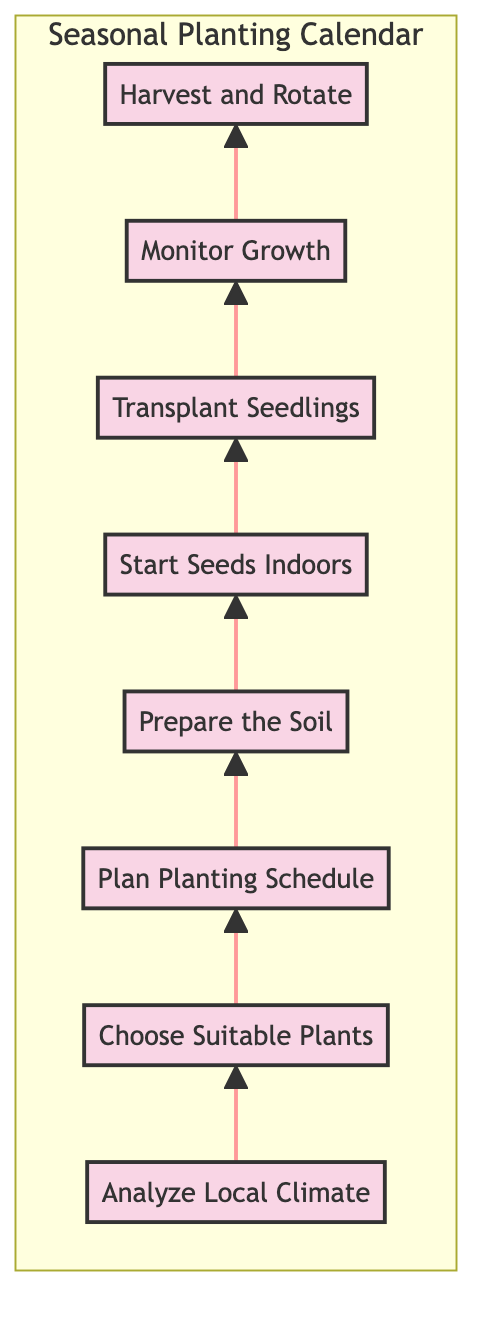What is the first step in the seasonal planting calendar? The first step is represented as the bottom node in the flowchart, which shows "Analyze Local Climate" as the initial action to take before any other steps.
Answer: Analyze Local Climate How many steps are there in total? Counting each step in the flowchart from the bottom to the top reveals there are eight distinct steps listed sequentially.
Answer: 8 What comes after "Prepare the Soil"? By following the arrows in the flowchart, we see that "Start Seeds Indoors" directly follows "Prepare the Soil" as the next step in the process.
Answer: Start Seeds Indoors Which step involves monitoring plants for issues? Referring to the flowchart, the step labeled "Monitor Growth" explicitly describes the actions of checking for pests, diseases, and nutrient deficiencies.
Answer: Monitor Growth What is the last step in the sequence? The last step in the flowchart is the topmost node, which indicates the final action to complete the seasonal planting calendar: "Harvest and Rotate."
Answer: Harvest and Rotate Which step includes enriching the soil? The step that describes enriching the soil is "Prepare the Soil," which is focused on soil preparation necessary for planting.
Answer: Prepare the Soil How many steps are there between "Choose Suitable Plants" and "Transplant Seedlings"? To find the number of steps between these two nodes, we count: from "Choose Suitable Plants" to "Plan Planting Schedule" (1), "Prepare the Soil" (2), "Start Seeds Indoors" (3), and finally "Transplant Seedlings" (4), totaling four steps.
Answer: 4 What is the relationship between "Start Seeds Indoors" and "Transplant Seedlings"? The relationship is sequential; "Start Seeds Indoors" is the preparatory step that occurs before the subsequent action of "Transplant Seedlings."
Answer: Sequential relationship 